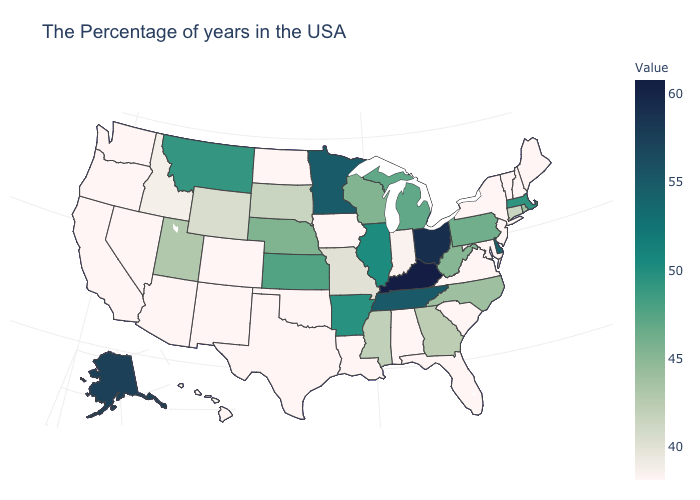Does the map have missing data?
Give a very brief answer. No. Does Florida have the highest value in the South?
Quick response, please. No. Does Virginia have a lower value than Alaska?
Quick response, please. Yes. Does Washington have the highest value in the West?
Short answer required. No. Which states have the lowest value in the USA?
Short answer required. Maine, New Hampshire, Vermont, New York, New Jersey, Maryland, Virginia, South Carolina, Florida, Alabama, Louisiana, Iowa, Oklahoma, Texas, North Dakota, Colorado, New Mexico, Arizona, Nevada, California, Washington, Oregon, Hawaii. Does Rhode Island have the lowest value in the Northeast?
Write a very short answer. No. Does Florida have the lowest value in the South?
Concise answer only. Yes. 